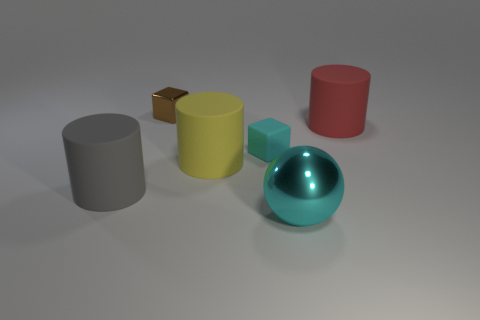What might be the material of the objects? The objects appear to have a matte finish, except for the ball and the small cube, which have a reflective surface. This suggests that the objects could be made of various materials, with the ball and the cube possibly being metallic or plastic, and the other objects could be made of clay or another opaque material. How can you tell? The difference in reflectiveness and the way light interacts with the surfaces of these objects provide clues about their material composition. Glossy reflections typically indicate a smoother and possibly harder surface, perhaps metal or plastic, while dull, diffuse reflections suggest a rougher texture, like clay or stone. 